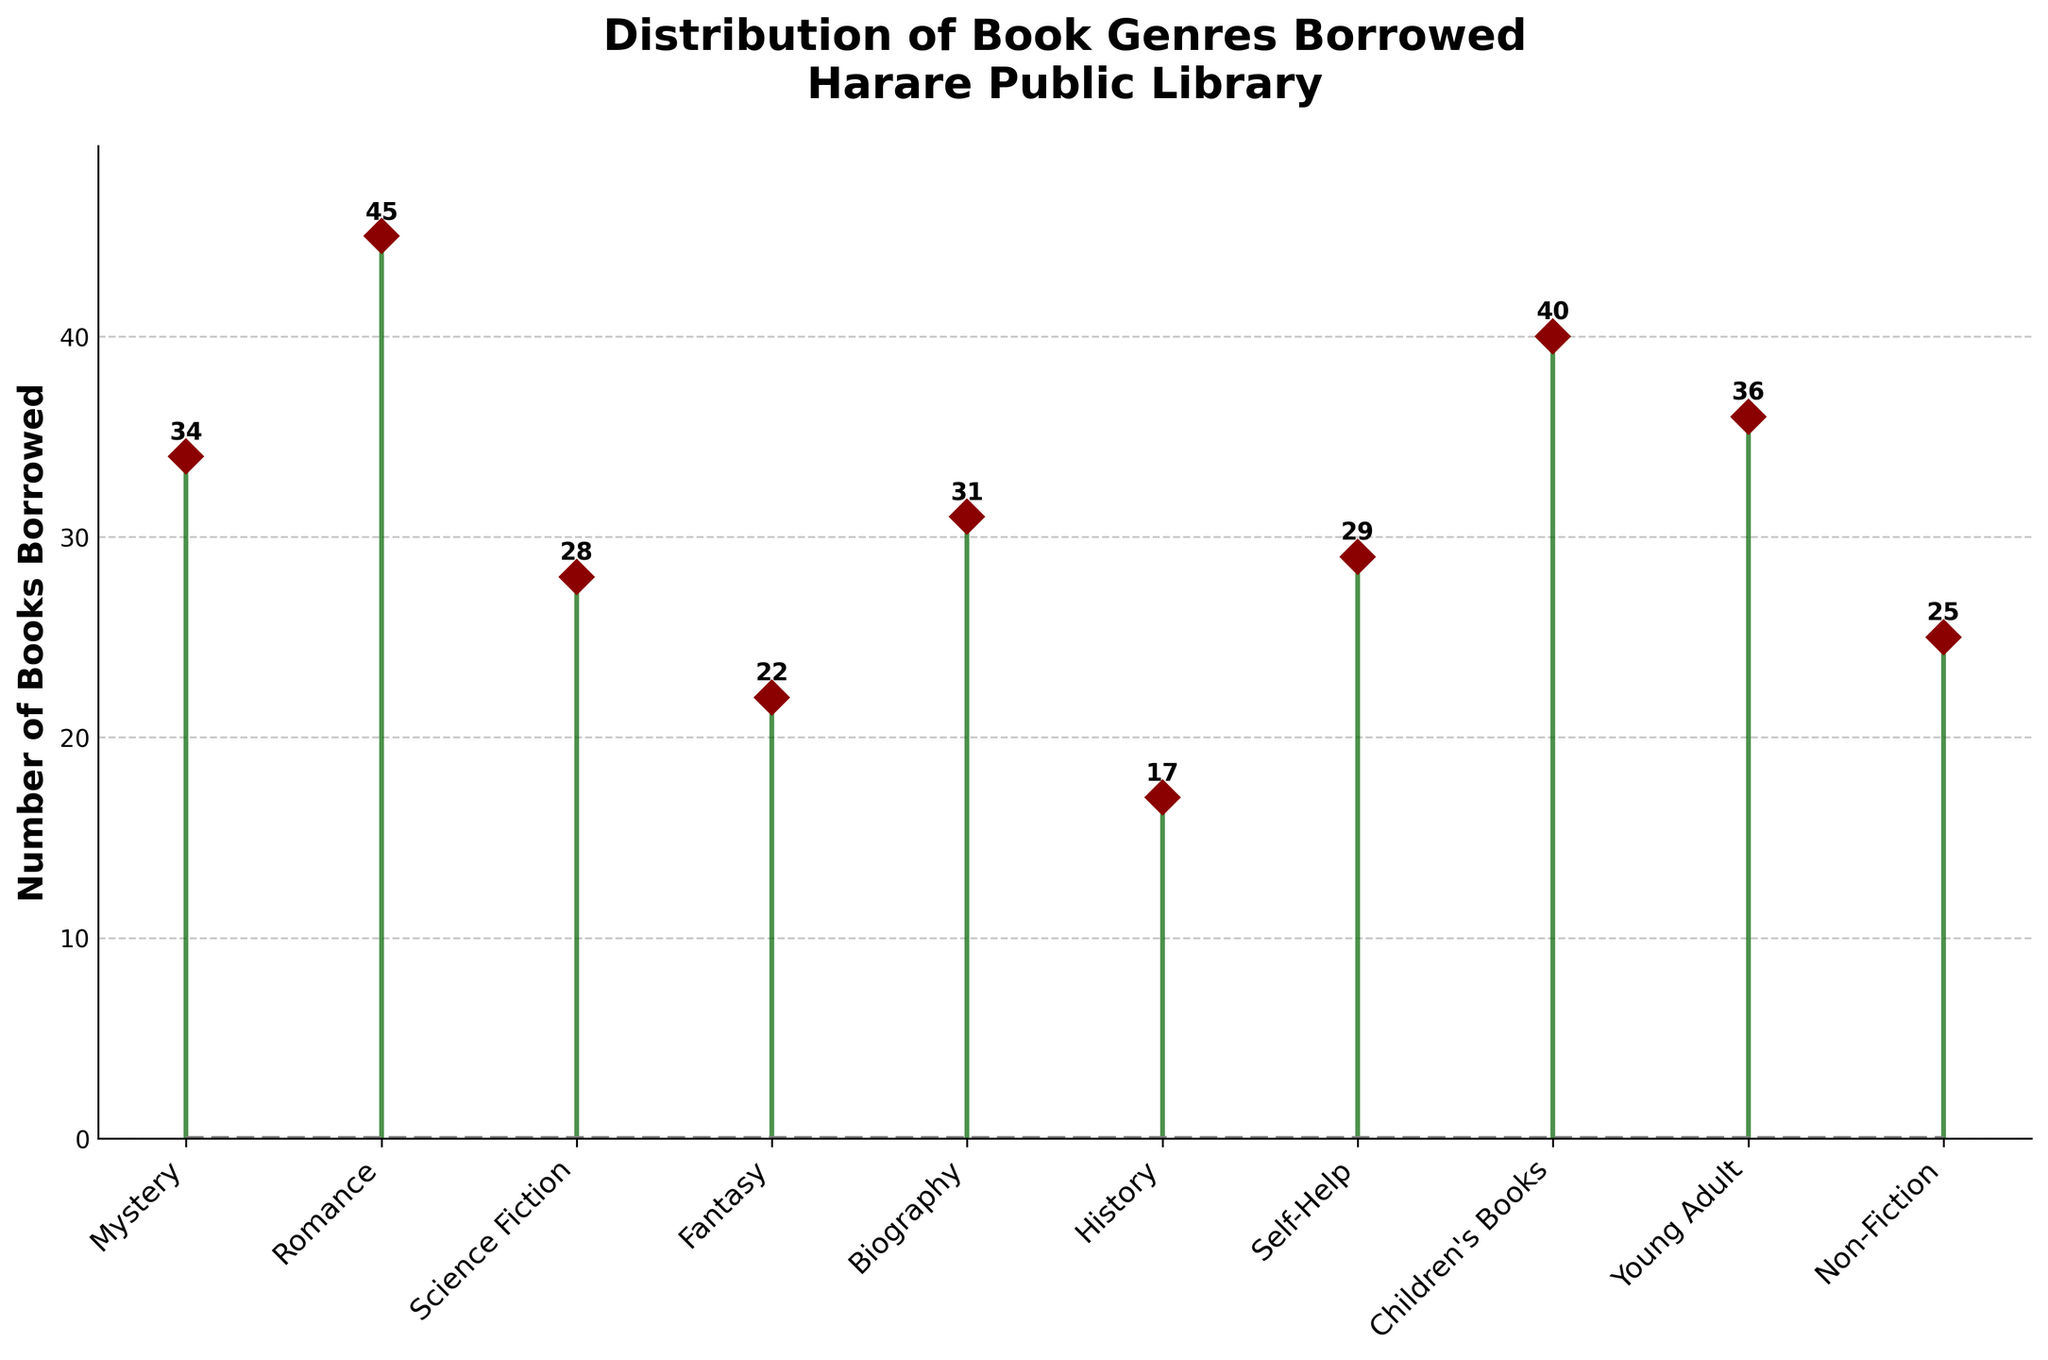What is the title of the stem plot? The title is displayed prominently at the top of the figure.
Answer: Distribution of Book Genres Borrowed from Harare Public Library How many genres were recorded in the data? Count the number of different genres listed along the x-axis.
Answer: 10 Which genre had the highest number of books borrowed? Locate the stem (the vertical line) with the highest peak on the plot.
Answer: Romance How many books were borrowed in the Mystery genre? Look for the point labeled 'Mystery' on the x-axis and read the value at the top of its stem.
Answer: 34 What is the total number of books borrowed for Science Fiction and Fantasy genres combined? Add the number of books borrowed for Science Fiction (28) and Fantasy (22).
Answer: 50 Which genres had more books borrowed than Biography? Identify the genres with a higher count than the stem for Biography (31).
Answer: Romance, Young Adult, Children's Books How many books were borrowed in total across all genres? Sum the counts of all the individual genres.
Answer: 34 + 45 + 28 + 22 + 31 + 17 + 29 + 40 + 36 + 25 = 307 Which genre had the least number of books borrowed? Find the stem with the lowest peak on the plot.
Answer: History How does the borrowing count for Self-Help compare to Non-Fiction? Compare the stems for Self-Help (29) and Non-Fiction (25).
Answer: Self-Help had 4 more books borrowed than Non-Fiction What is the average number of books borrowed per genre? Calculate the total number of books borrowed (307) and divide by the number of genres (10).
Answer: 30.7 